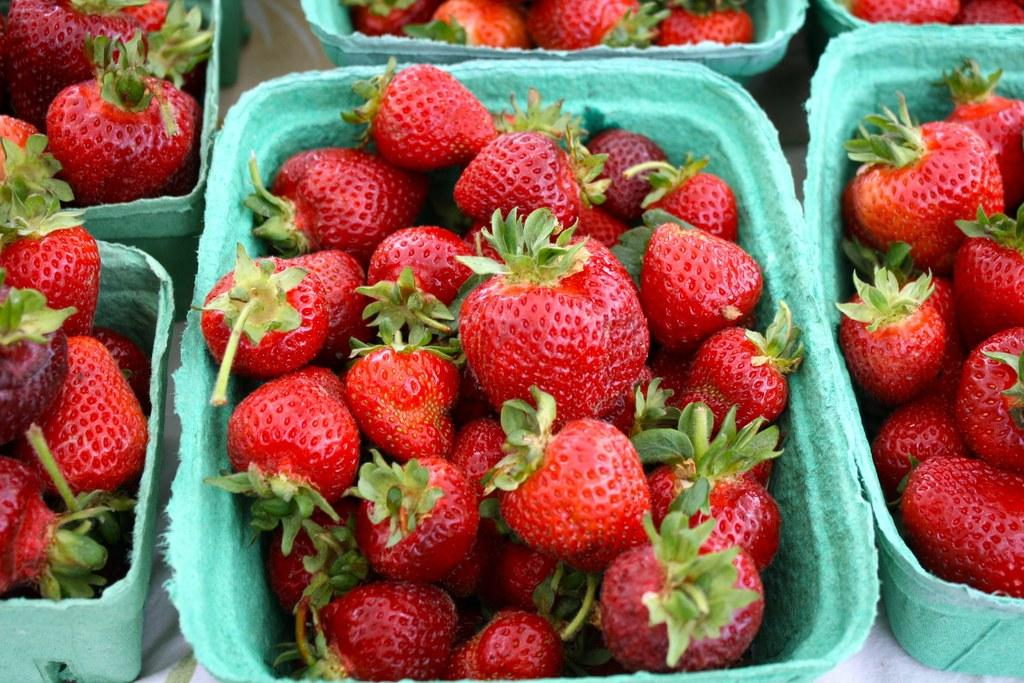What is the main structure in the center of the image? There is a platform in the center of the image. What is placed on the platform? There are baskets on the platform. What are the baskets filled with? The baskets contain strawberries. Can you see any mountains in the background of the image? There is no mention of mountains in the image, so we cannot determine if they are present or not. 